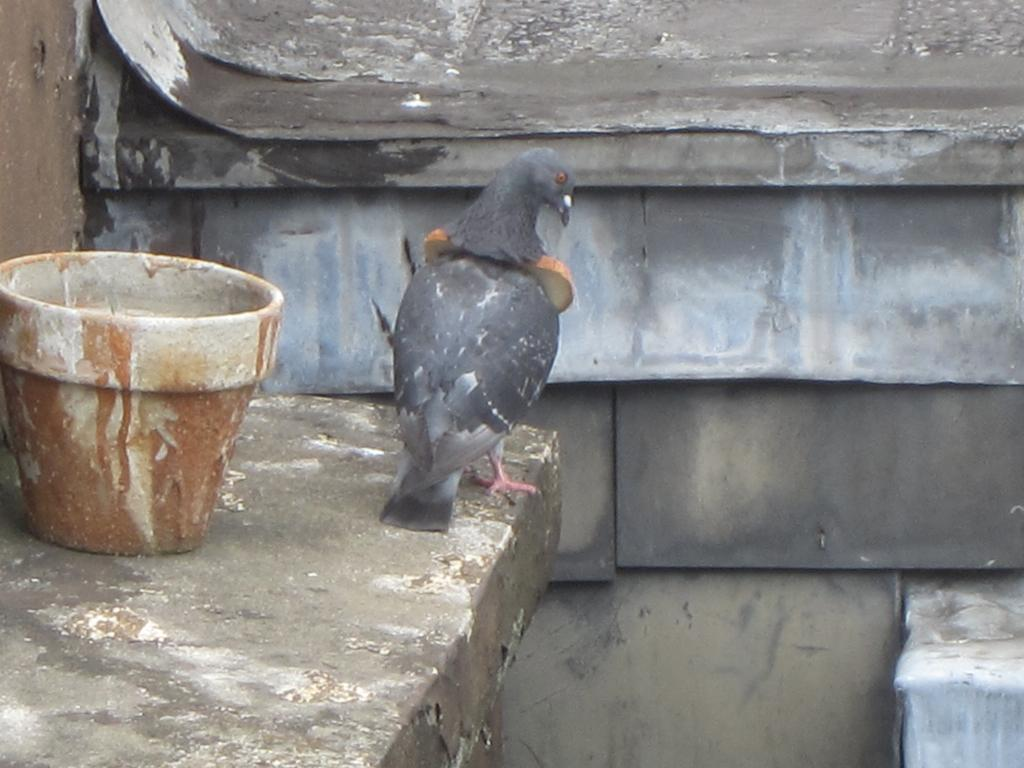What type of animal can be seen in the image? There is a bird in the image. Where is the bird located in the image? The bird is standing on a platform. What other object is present in the image? There is a pot in the image. What can be seen in the background of the image? There is a wall in the image. Is there a thread hanging from the bird's beak in the image? There is no thread visible in the image; only the bird, platform, pot, and wall are present. 